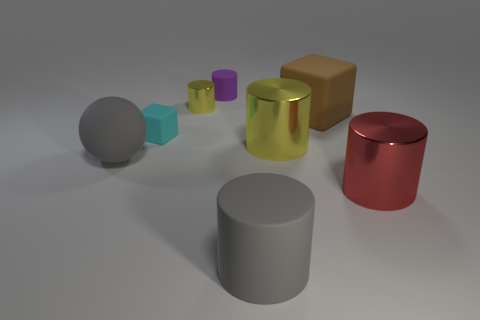Subtract 1 cylinders. How many cylinders are left? 4 Subtract all cyan cylinders. Subtract all red blocks. How many cylinders are left? 5 Add 2 big red metal balls. How many objects exist? 10 Subtract all cylinders. How many objects are left? 3 Subtract 1 brown blocks. How many objects are left? 7 Subtract all large yellow blocks. Subtract all matte blocks. How many objects are left? 6 Add 6 big matte cylinders. How many big matte cylinders are left? 7 Add 5 large purple matte cylinders. How many large purple matte cylinders exist? 5 